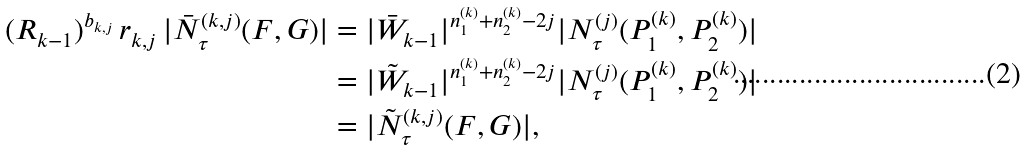<formula> <loc_0><loc_0><loc_500><loc_500>( R _ { k - 1 } ) ^ { b _ { k , j } } \, r _ { k , j } \, | \bar { N } _ { \tau } ^ { ( k , j ) } ( F , G ) | & = | \bar { W } _ { k - 1 } | ^ { n _ { 1 } ^ { ( k ) } + n _ { 2 } ^ { ( k ) } - 2 j } | N _ { \tau } ^ { ( j ) } ( P _ { 1 } ^ { ( k ) } , P _ { 2 } ^ { ( k ) } ) | \\ & = | \tilde { W } _ { k - 1 } | ^ { n _ { 1 } ^ { ( k ) } + n _ { 2 } ^ { ( k ) } - 2 j } | N _ { \tau } ^ { ( j ) } ( P _ { 1 } ^ { ( k ) } , P _ { 2 } ^ { ( k ) } ) | \\ & = | \tilde { N } _ { \tau } ^ { ( k , j ) } ( F , G ) | ,</formula> 